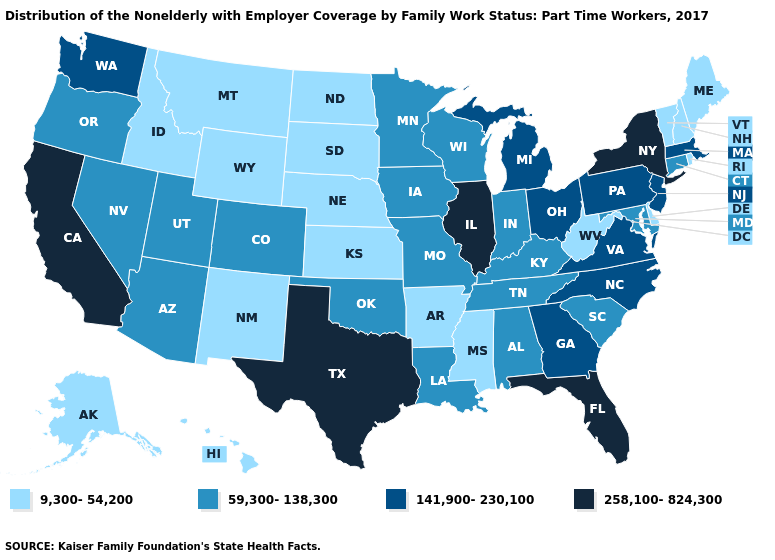Which states have the lowest value in the USA?
Quick response, please. Alaska, Arkansas, Delaware, Hawaii, Idaho, Kansas, Maine, Mississippi, Montana, Nebraska, New Hampshire, New Mexico, North Dakota, Rhode Island, South Dakota, Vermont, West Virginia, Wyoming. Name the states that have a value in the range 258,100-824,300?
Answer briefly. California, Florida, Illinois, New York, Texas. What is the value of Idaho?
Concise answer only. 9,300-54,200. What is the value of Missouri?
Be succinct. 59,300-138,300. Does the first symbol in the legend represent the smallest category?
Quick response, please. Yes. What is the value of Kansas?
Short answer required. 9,300-54,200. Name the states that have a value in the range 9,300-54,200?
Short answer required. Alaska, Arkansas, Delaware, Hawaii, Idaho, Kansas, Maine, Mississippi, Montana, Nebraska, New Hampshire, New Mexico, North Dakota, Rhode Island, South Dakota, Vermont, West Virginia, Wyoming. Among the states that border Iowa , does Nebraska have the lowest value?
Quick response, please. Yes. What is the value of Washington?
Short answer required. 141,900-230,100. Which states have the lowest value in the South?
Concise answer only. Arkansas, Delaware, Mississippi, West Virginia. What is the lowest value in states that border Minnesota?
Short answer required. 9,300-54,200. What is the value of Georgia?
Quick response, please. 141,900-230,100. Name the states that have a value in the range 59,300-138,300?
Short answer required. Alabama, Arizona, Colorado, Connecticut, Indiana, Iowa, Kentucky, Louisiana, Maryland, Minnesota, Missouri, Nevada, Oklahoma, Oregon, South Carolina, Tennessee, Utah, Wisconsin. Among the states that border Idaho , does Wyoming have the highest value?
Keep it brief. No. Name the states that have a value in the range 59,300-138,300?
Keep it brief. Alabama, Arizona, Colorado, Connecticut, Indiana, Iowa, Kentucky, Louisiana, Maryland, Minnesota, Missouri, Nevada, Oklahoma, Oregon, South Carolina, Tennessee, Utah, Wisconsin. 